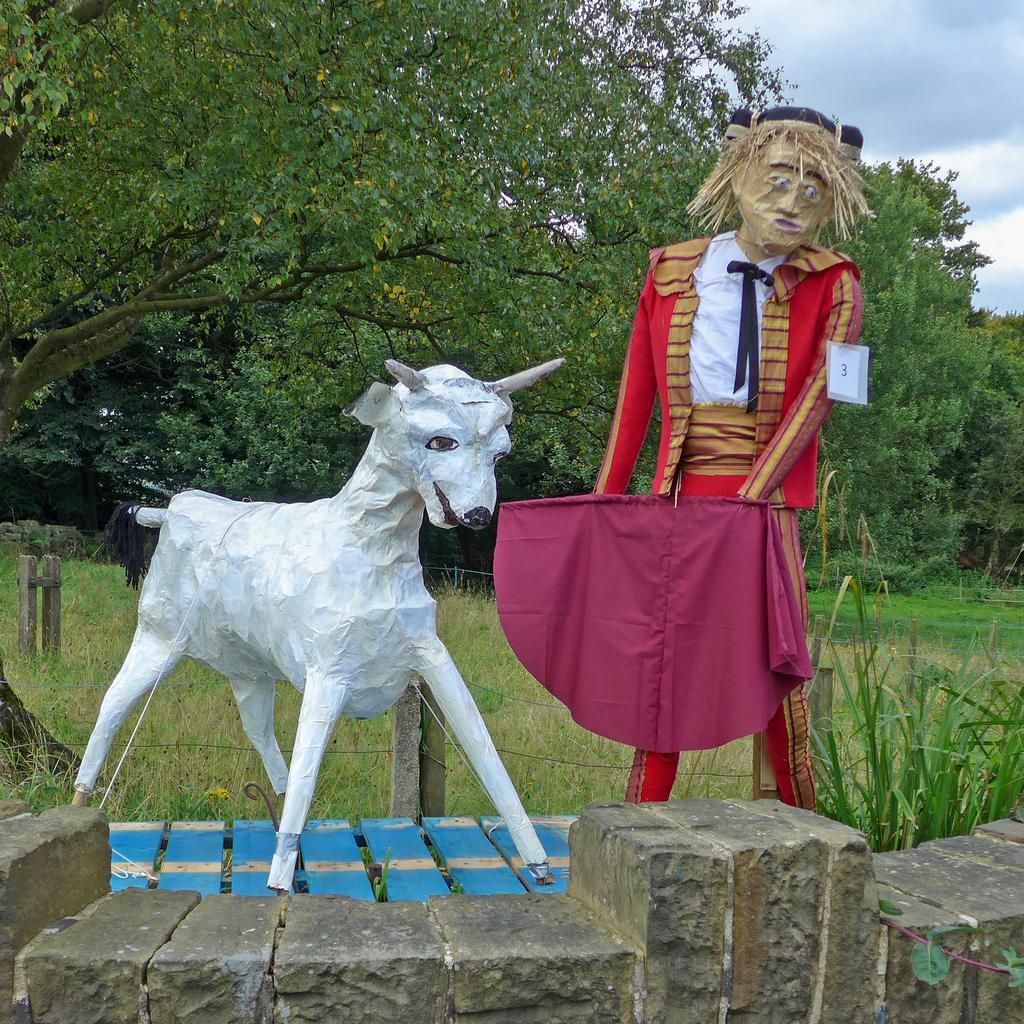What is located in the foreground of the picture? There is a wall in the foreground of the picture. What can be seen on the table in the foreground? There are sculptures of a goat and a girl on a table in the foreground. What type of vegetation is visible in the background of the picture? There are plants, grass, and trees in the background of the picture. What is the condition of the sky in the picture? The sky is cloudy in the picture. Can you tell me what type of haircut the girl in the sculpture has? The sculpture is not a real person, so it does not have a haircut. How many roses can be seen in the picture? There are no roses present in the image. 